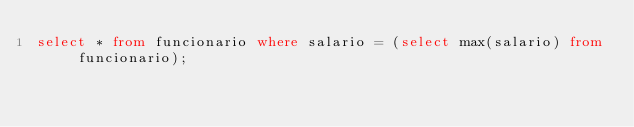<code> <loc_0><loc_0><loc_500><loc_500><_SQL_>select * from funcionario where salario = (select max(salario) from funcionario);
</code> 